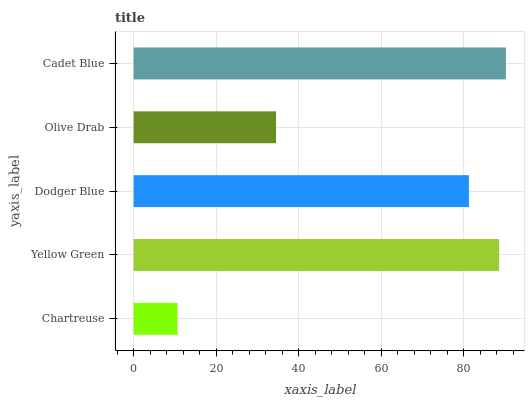Is Chartreuse the minimum?
Answer yes or no. Yes. Is Cadet Blue the maximum?
Answer yes or no. Yes. Is Yellow Green the minimum?
Answer yes or no. No. Is Yellow Green the maximum?
Answer yes or no. No. Is Yellow Green greater than Chartreuse?
Answer yes or no. Yes. Is Chartreuse less than Yellow Green?
Answer yes or no. Yes. Is Chartreuse greater than Yellow Green?
Answer yes or no. No. Is Yellow Green less than Chartreuse?
Answer yes or no. No. Is Dodger Blue the high median?
Answer yes or no. Yes. Is Dodger Blue the low median?
Answer yes or no. Yes. Is Yellow Green the high median?
Answer yes or no. No. Is Cadet Blue the low median?
Answer yes or no. No. 